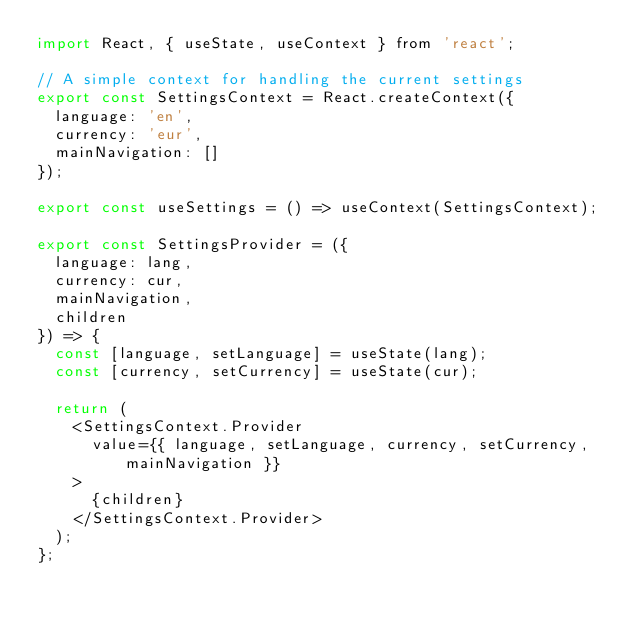<code> <loc_0><loc_0><loc_500><loc_500><_JavaScript_>import React, { useState, useContext } from 'react';

// A simple context for handling the current settings
export const SettingsContext = React.createContext({
  language: 'en',
  currency: 'eur',
  mainNavigation: []
});

export const useSettings = () => useContext(SettingsContext);

export const SettingsProvider = ({
  language: lang,
  currency: cur,
  mainNavigation,
  children
}) => {
  const [language, setLanguage] = useState(lang);
  const [currency, setCurrency] = useState(cur);

  return (
    <SettingsContext.Provider
      value={{ language, setLanguage, currency, setCurrency, mainNavigation }}
    >
      {children}
    </SettingsContext.Provider>
  );
};
</code> 